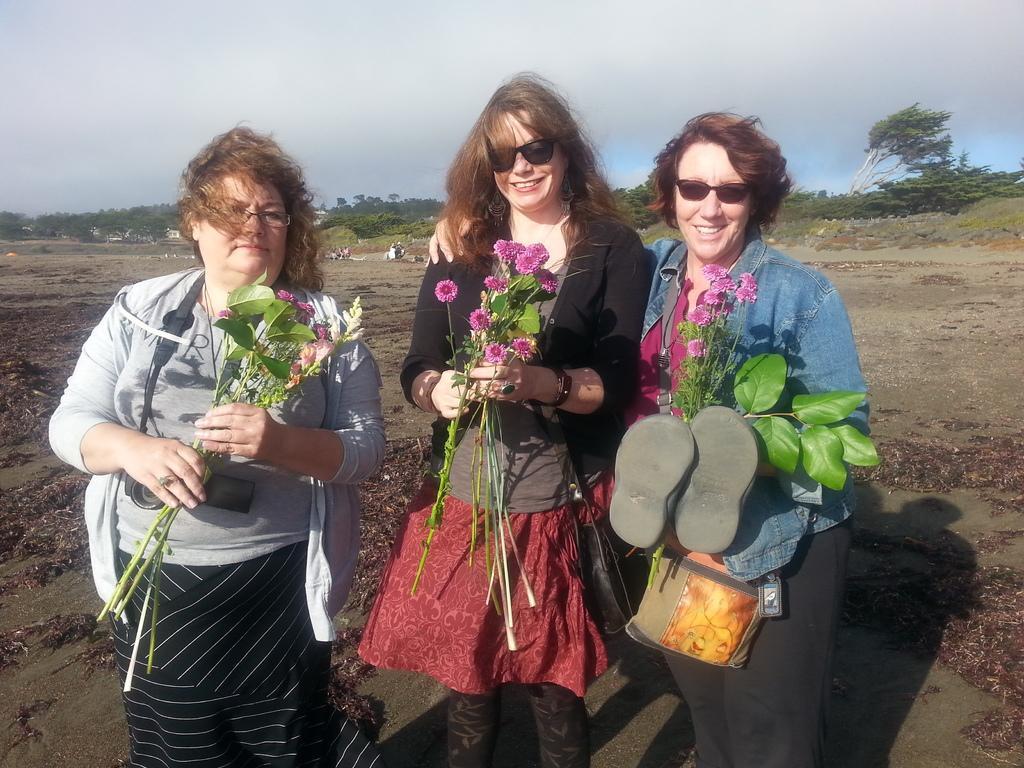Can you describe this image briefly? In this image we can see three ladies standing and holding flowers. The lady standing on the right is holding slippers. In the background there are trees and sky. 